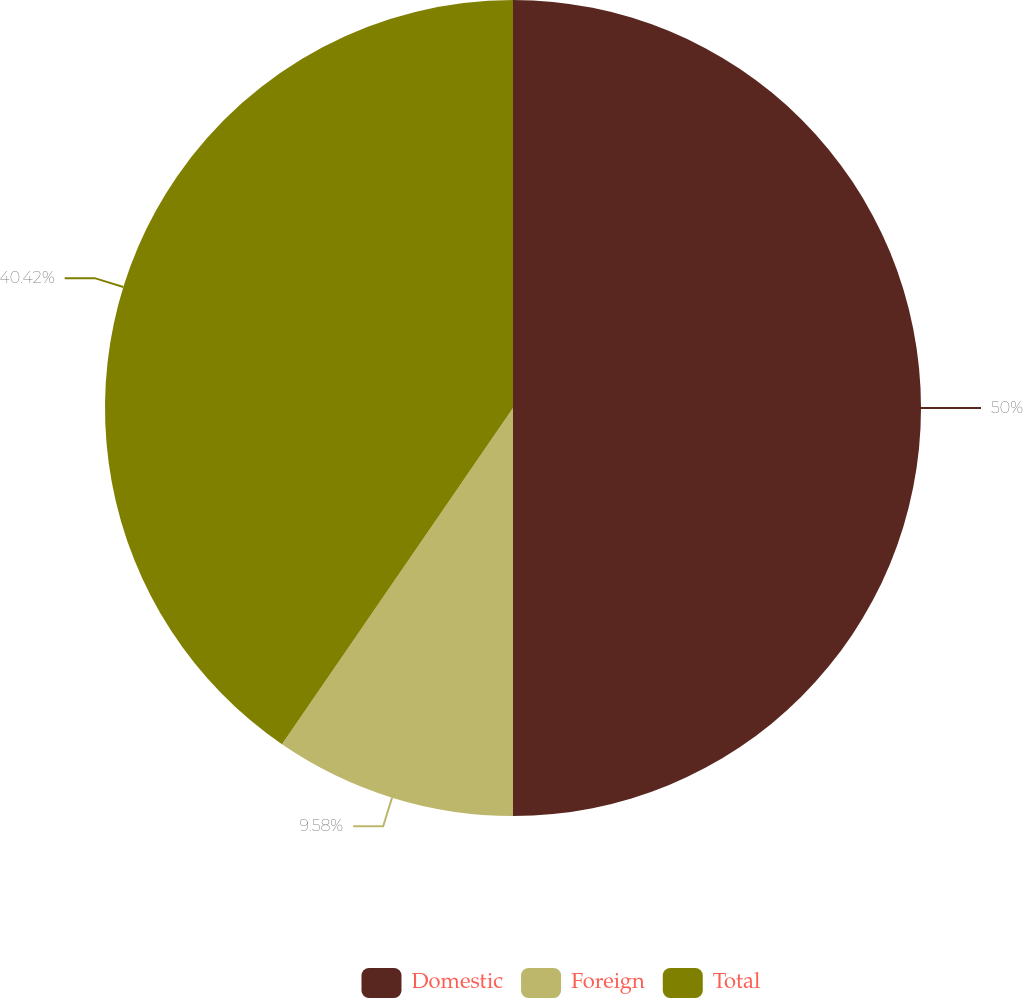Convert chart to OTSL. <chart><loc_0><loc_0><loc_500><loc_500><pie_chart><fcel>Domestic<fcel>Foreign<fcel>Total<nl><fcel>50.0%<fcel>9.58%<fcel>40.42%<nl></chart> 